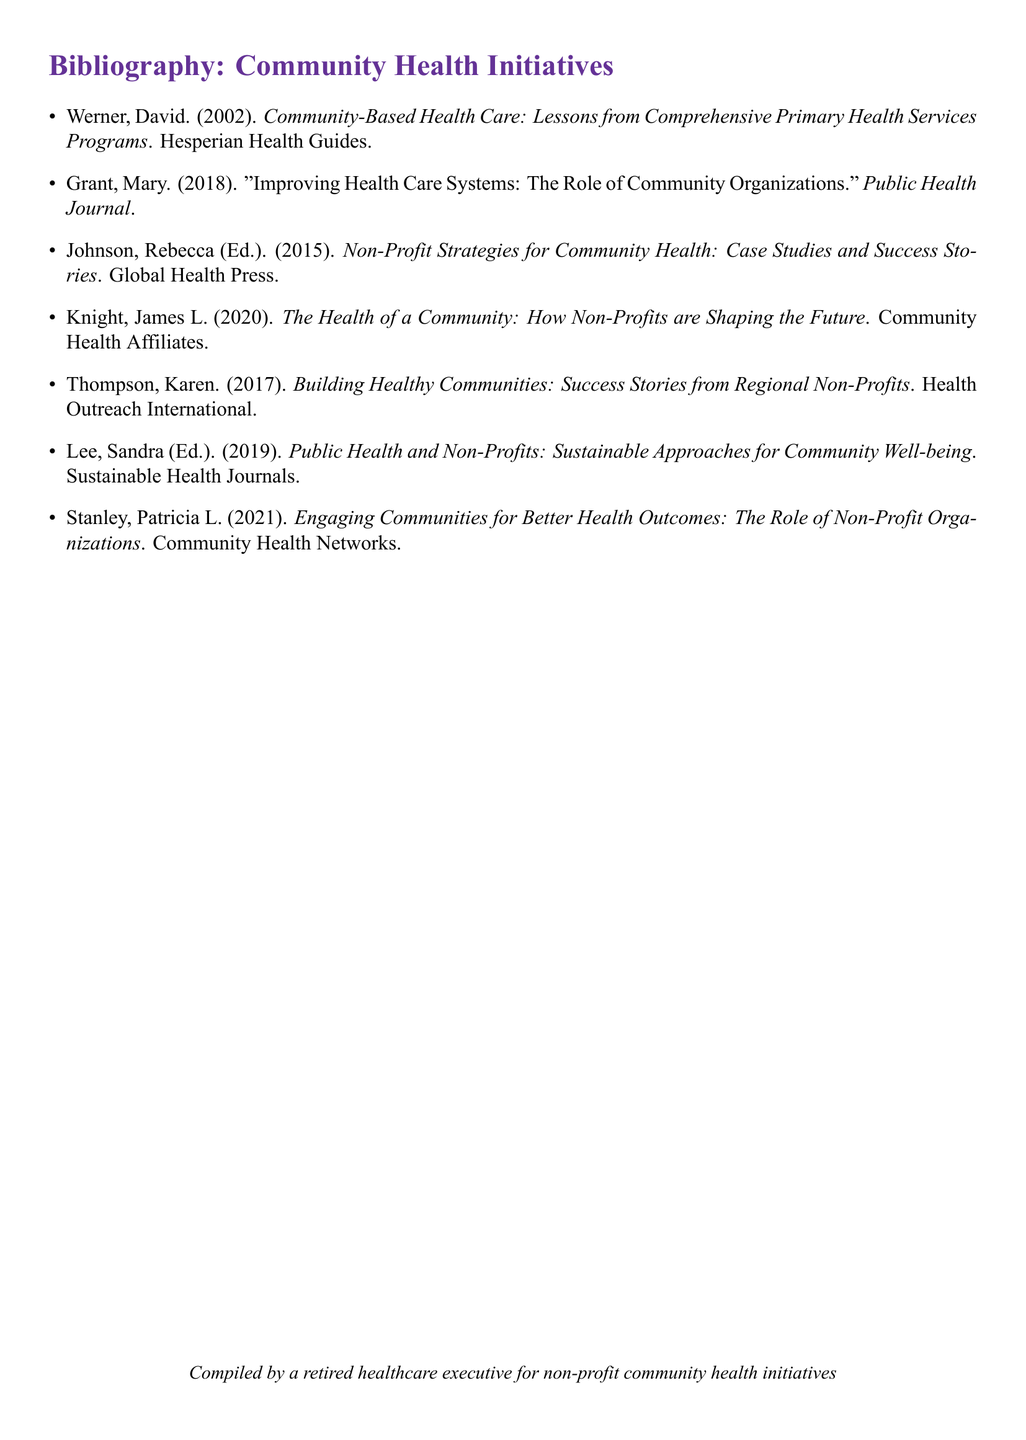What is the title of David Werner's book? The title of David Werner's book is mentioned in the bibliography section as it is the first entry.
Answer: Community-Based Health Care: Lessons from Comprehensive Primary Health Services Programs How many publications are authored or edited by individuals named Lee? By counting the entries in the document, we can find that only one publication has an author or editor named Lee.
Answer: 1 In which year was "Building Healthy Communities: Success Stories from Regional Non-Profits" published? The publication year can be found by reviewing the relevant entry in the bibliography.
Answer: 2017 Who edited the publication "Public Health and Non-Profits: Sustainable Approaches for Community Well-being"? The editor's name is indicated in the bibliography entry for this publication.
Answer: Sandra Lee Which organization published the book written by James L. Knight? The name of the publishing organization is shown in the bibliography next to the title of Knight's book.
Answer: Community Health Affiliates What common theme is reflected in the titles of multiple entries in this bibliography? By analyzing the titles, we can ascertain that the common theme relates to community health initiatives.
Answer: Community health How many years span between the earliest and the latest publication in this bibliography? By identifying the years of the earliest and latest publications, a simple subtraction will provide the span.
Answer: 19 What type of document is represented in the provided text? This question focuses on identifying the kind of document that contains entries detailing sources and their authors.
Answer: Bibliography 